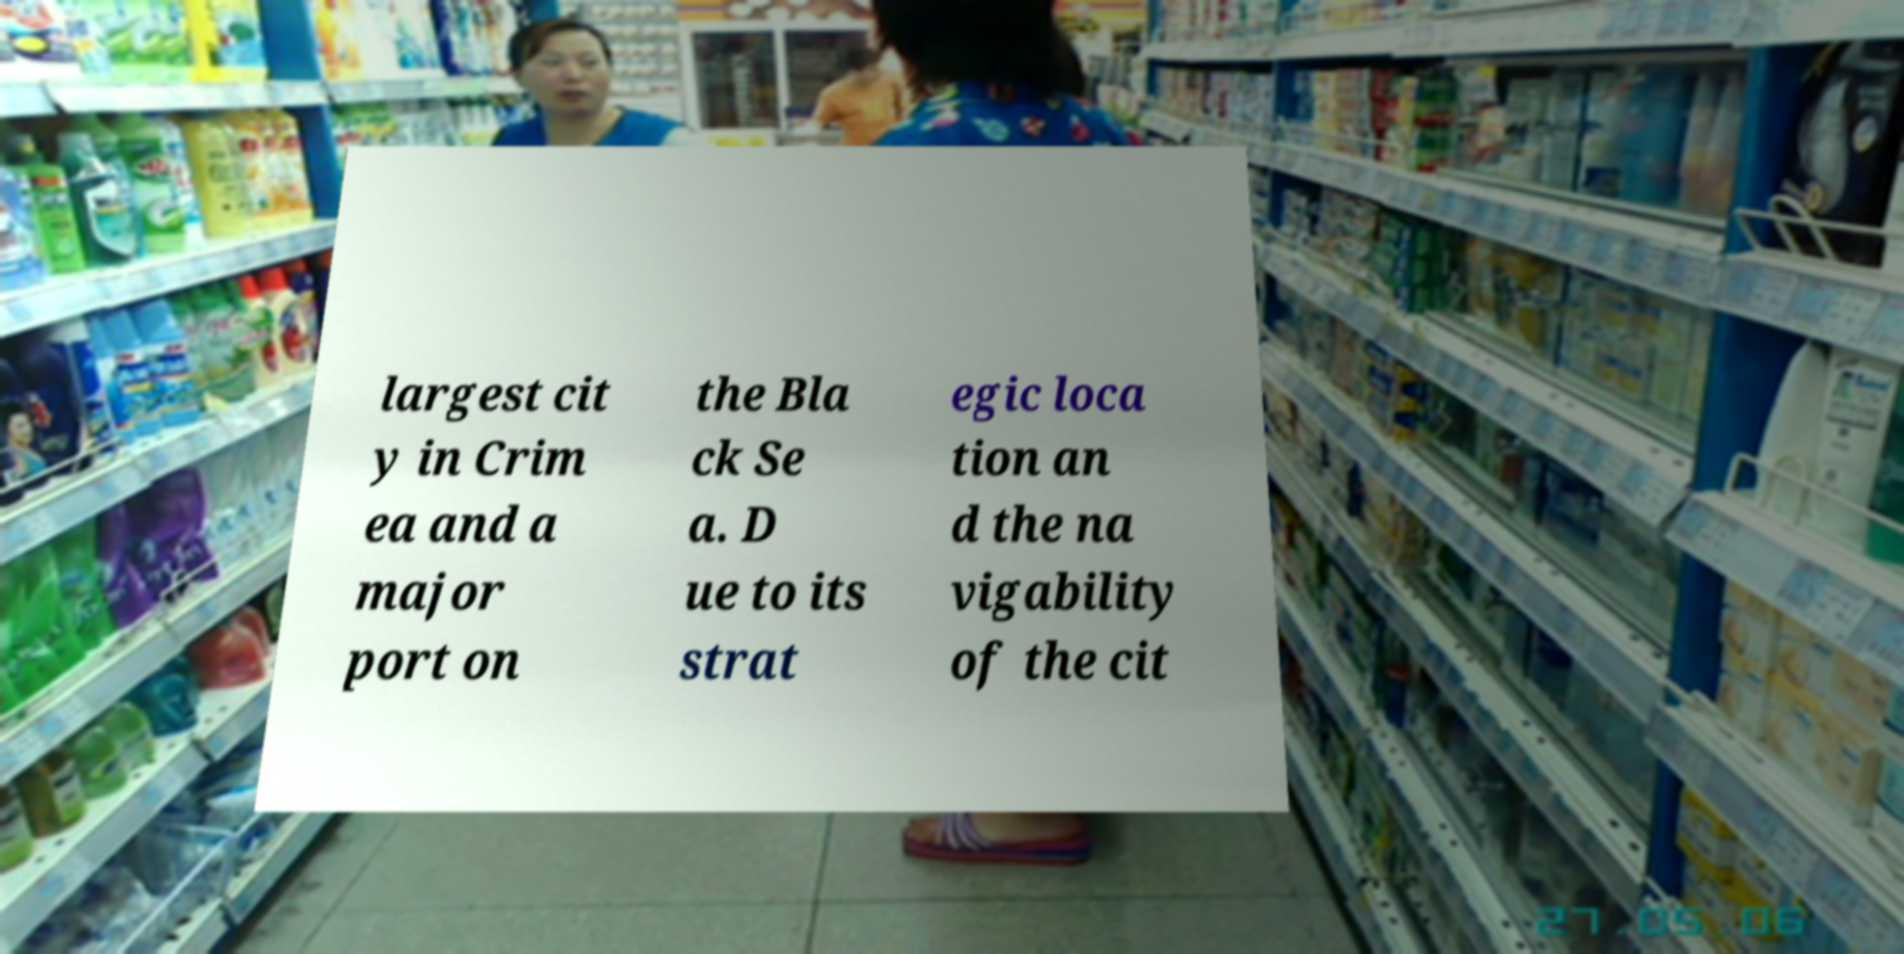Could you assist in decoding the text presented in this image and type it out clearly? largest cit y in Crim ea and a major port on the Bla ck Se a. D ue to its strat egic loca tion an d the na vigability of the cit 